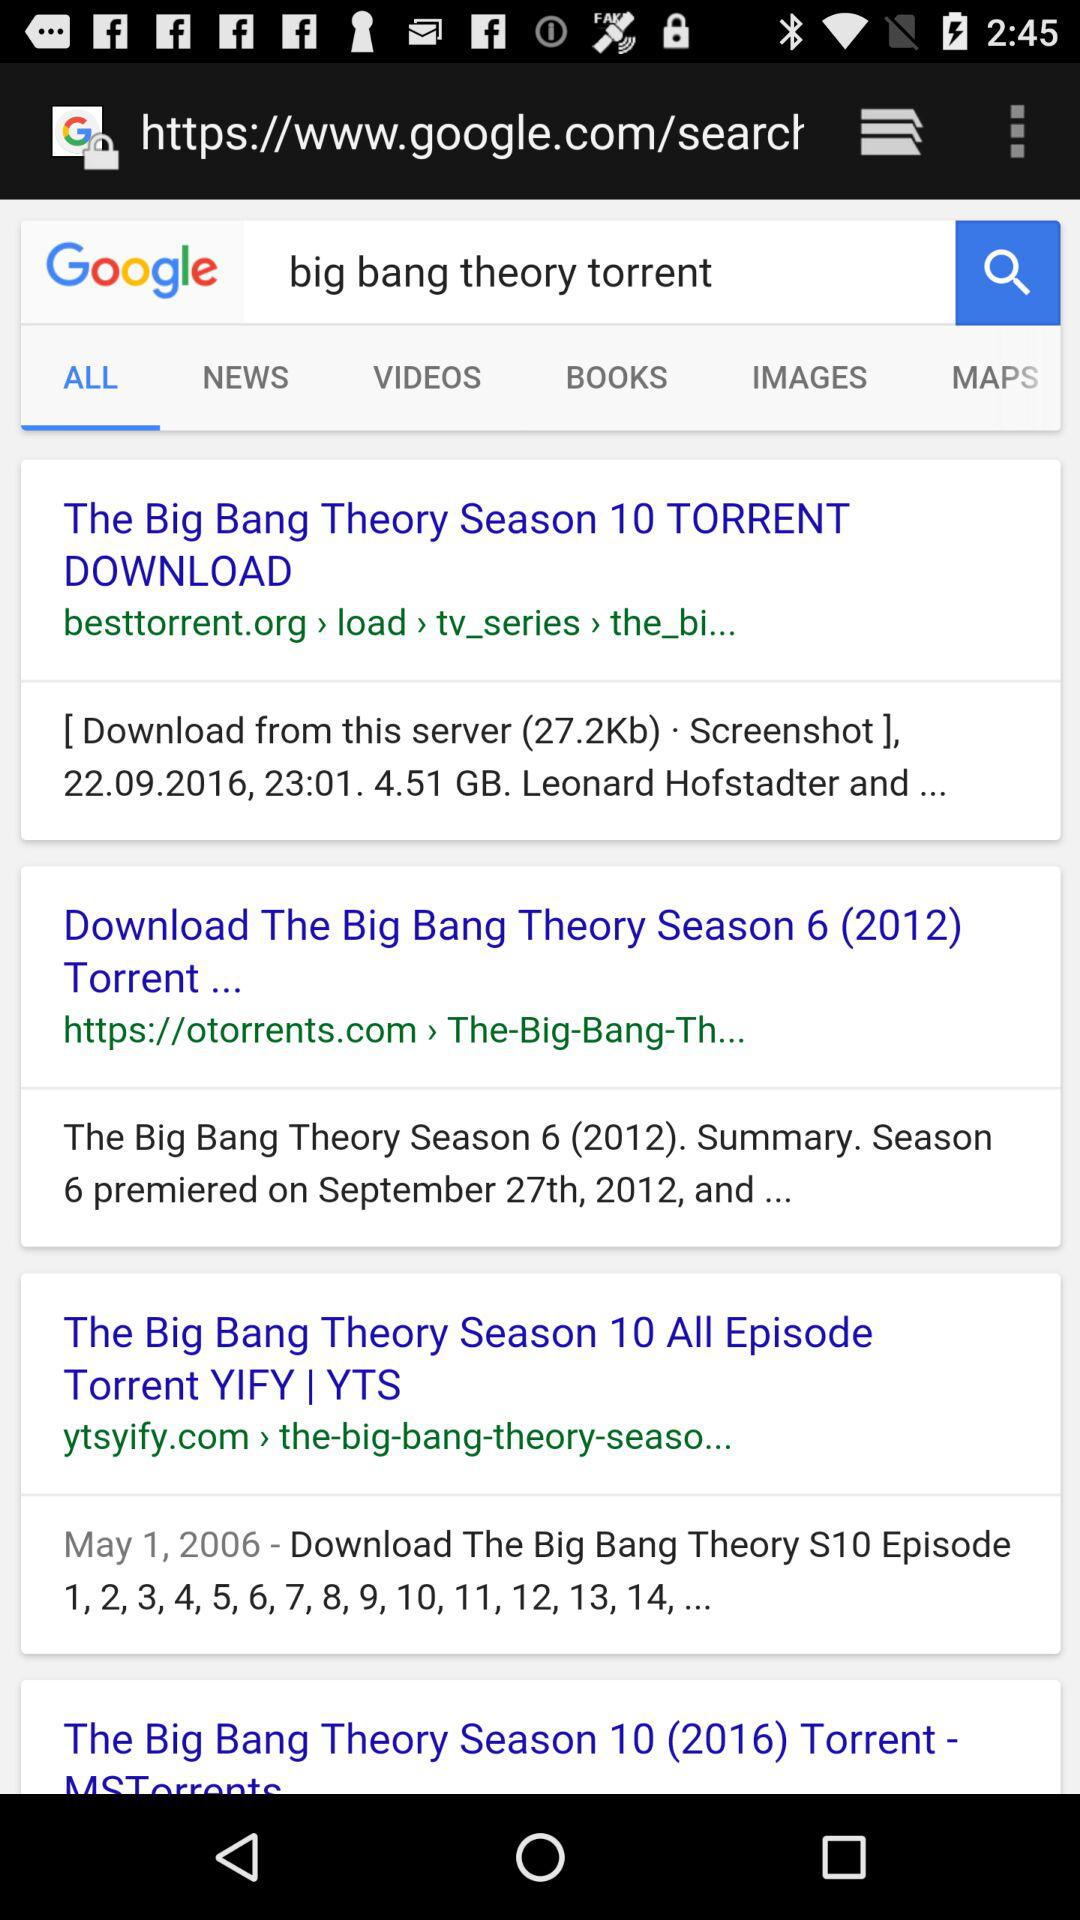How many results are there for the search term 'big bang theory torrent'?
Answer the question using a single word or phrase. 4 